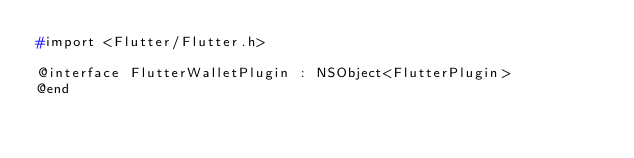Convert code to text. <code><loc_0><loc_0><loc_500><loc_500><_C_>#import <Flutter/Flutter.h>

@interface FlutterWalletPlugin : NSObject<FlutterPlugin>
@end
</code> 